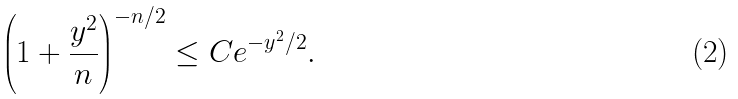<formula> <loc_0><loc_0><loc_500><loc_500>\left ( 1 + \frac { y ^ { 2 } } { n } \right ) ^ { - n / 2 } \leq C e ^ { - y ^ { 2 } / 2 } .</formula> 